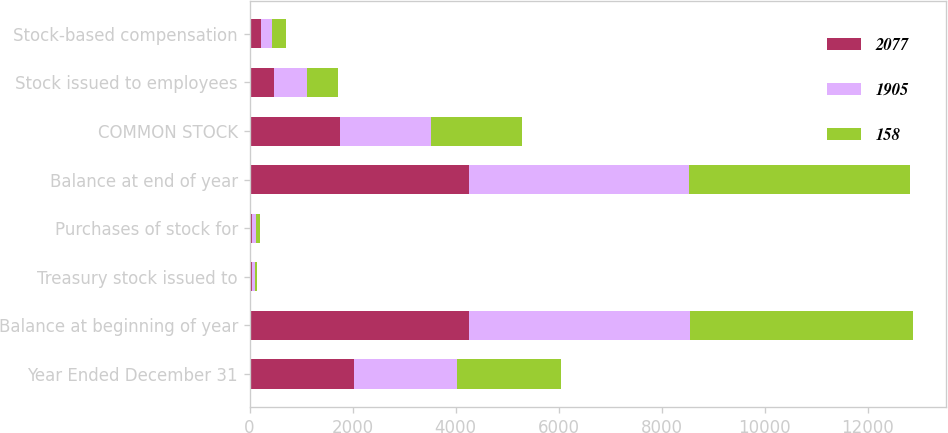<chart> <loc_0><loc_0><loc_500><loc_500><stacked_bar_chart><ecel><fcel>Year Ended December 31<fcel>Balance at beginning of year<fcel>Treasury stock issued to<fcel>Purchases of stock for<fcel>Balance at end of year<fcel>COMMON STOCK<fcel>Stock issued to employees<fcel>Stock-based compensation<nl><fcel>2077<fcel>2018<fcel>4259<fcel>48<fcel>39<fcel>4268<fcel>1760<fcel>467<fcel>225<nl><fcel>1905<fcel>2017<fcel>4288<fcel>53<fcel>82<fcel>4259<fcel>1760<fcel>655<fcel>219<nl><fcel>158<fcel>2016<fcel>4324<fcel>50<fcel>86<fcel>4288<fcel>1760<fcel>589<fcel>258<nl></chart> 